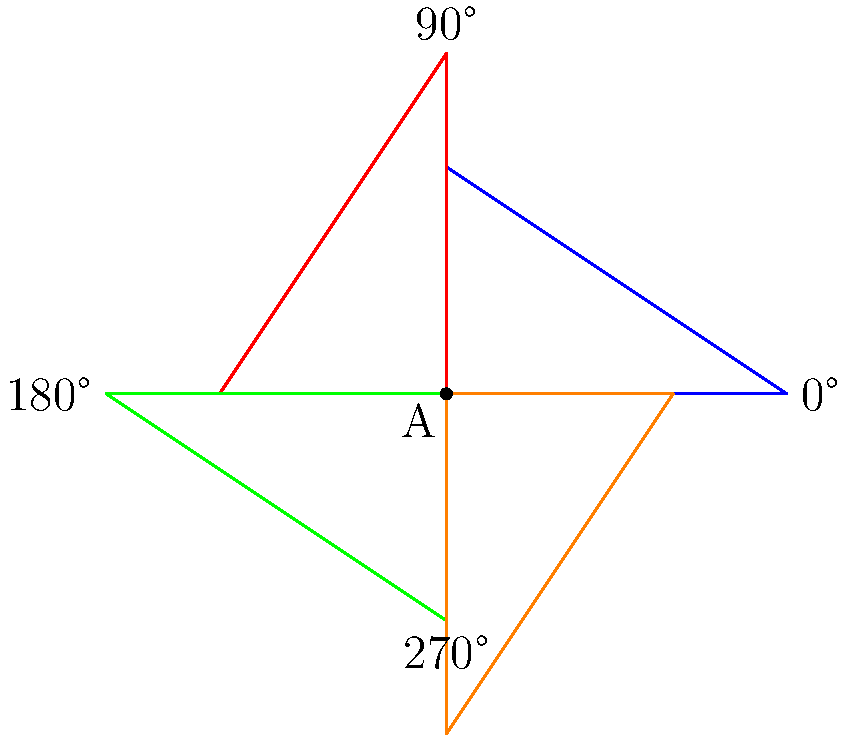A triangle ABC is rotated around point A to create a colorful pinwheel design for a children's learning tool about shapes and angles. If the original triangle (blue) is rotated 90° clockwise three times, what will be the final position and color of the triangle? Let's follow the rotation step-by-step:

1. The original triangle is blue and in the starting position.

2. After the first 90° clockwise rotation:
   - The triangle is now red
   - It has moved from the 1st quadrant to the 4th quadrant

3. After the second 90° clockwise rotation:
   - The triangle is now green
   - It has moved from the 4th quadrant to the 3rd quadrant

4. After the third 90° clockwise rotation:
   - The triangle is now orange
   - It has moved from the 3rd quadrant to the 2nd quadrant

5. The final position of the triangle is in the 2nd quadrant, which is equivalent to a single 270° clockwise rotation from the original position.

This rotation creates a visually appealing design that can be used to teach children about geometry, colors, and rotations in a fun and engaging way.
Answer: Orange, in the 2nd quadrant (270° from original position) 